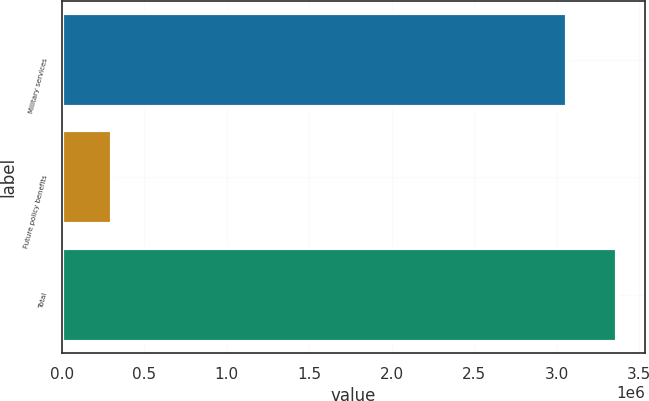Convert chart. <chart><loc_0><loc_0><loc_500><loc_500><bar_chart><fcel>Military services<fcel>Future policy benefits<fcel>Total<nl><fcel>3.05949e+06<fcel>305875<fcel>3.36544e+06<nl></chart> 